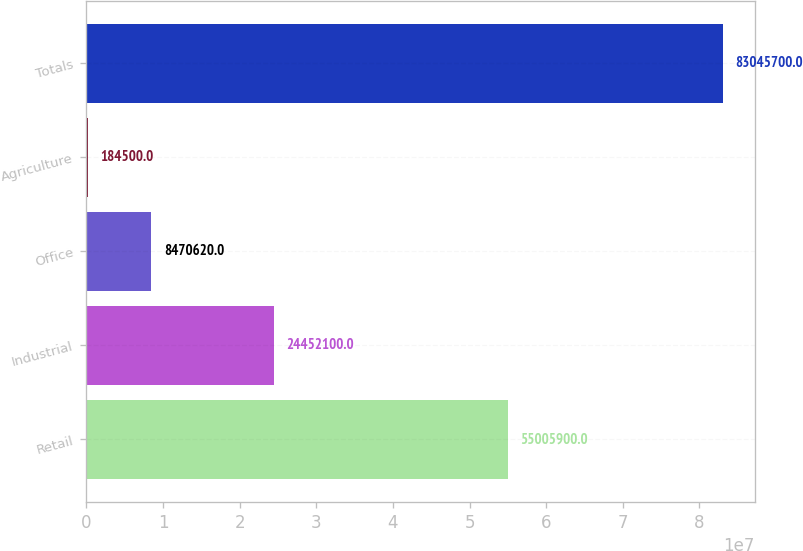Convert chart. <chart><loc_0><loc_0><loc_500><loc_500><bar_chart><fcel>Retail<fcel>Industrial<fcel>Office<fcel>Agriculture<fcel>Totals<nl><fcel>5.50059e+07<fcel>2.44521e+07<fcel>8.47062e+06<fcel>184500<fcel>8.30457e+07<nl></chart> 